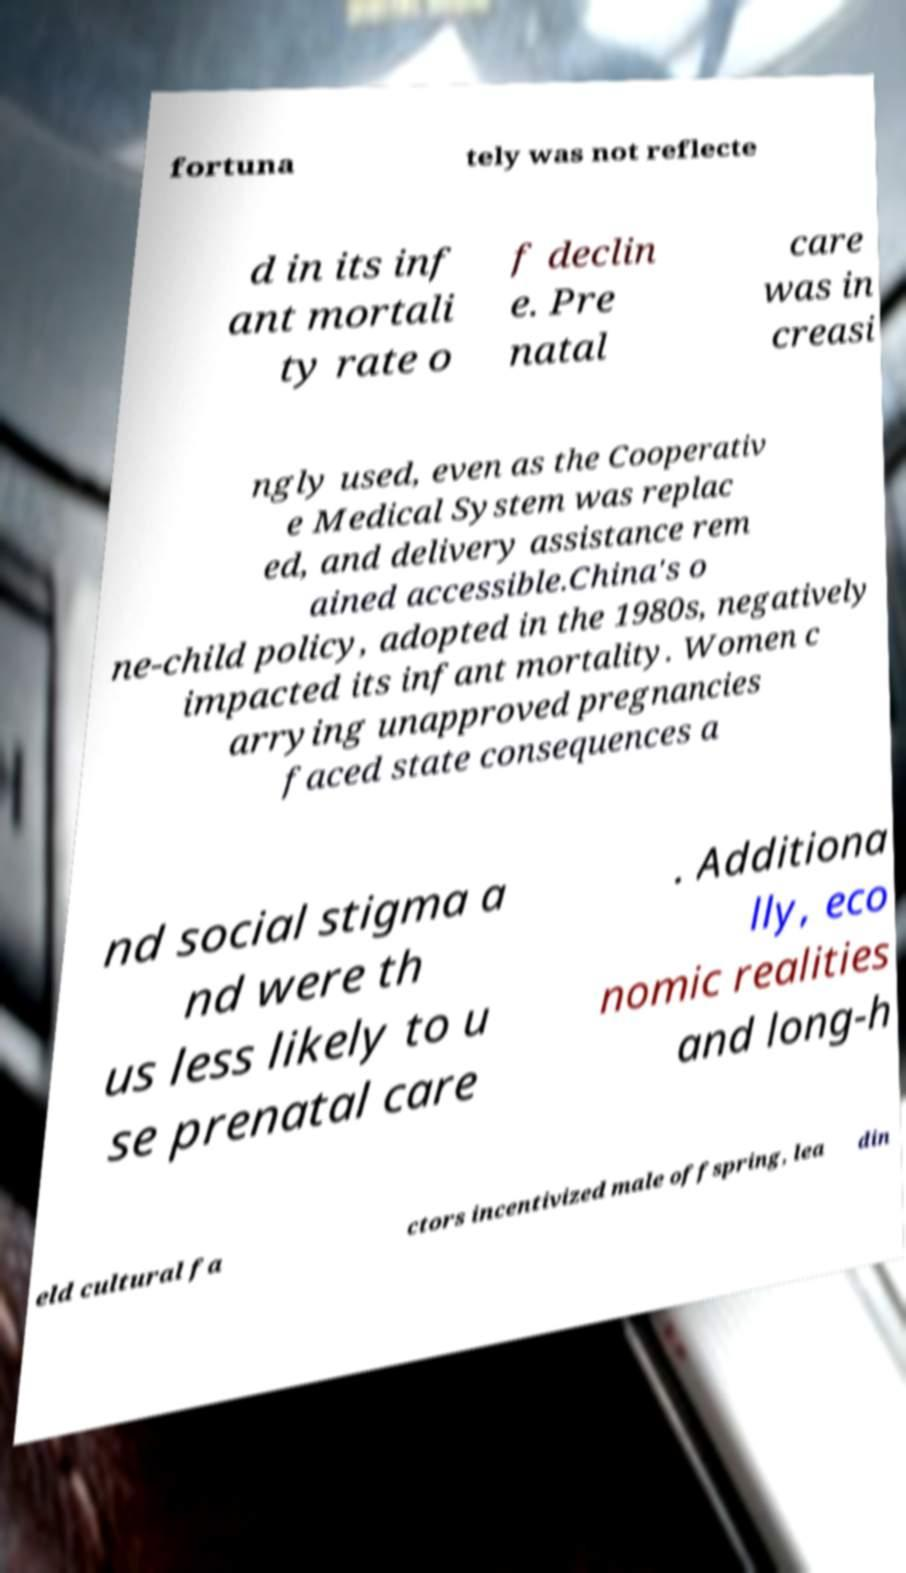Can you read and provide the text displayed in the image?This photo seems to have some interesting text. Can you extract and type it out for me? fortuna tely was not reflecte d in its inf ant mortali ty rate o f declin e. Pre natal care was in creasi ngly used, even as the Cooperativ e Medical System was replac ed, and delivery assistance rem ained accessible.China's o ne-child policy, adopted in the 1980s, negatively impacted its infant mortality. Women c arrying unapproved pregnancies faced state consequences a nd social stigma a nd were th us less likely to u se prenatal care . Additiona lly, eco nomic realities and long-h eld cultural fa ctors incentivized male offspring, lea din 